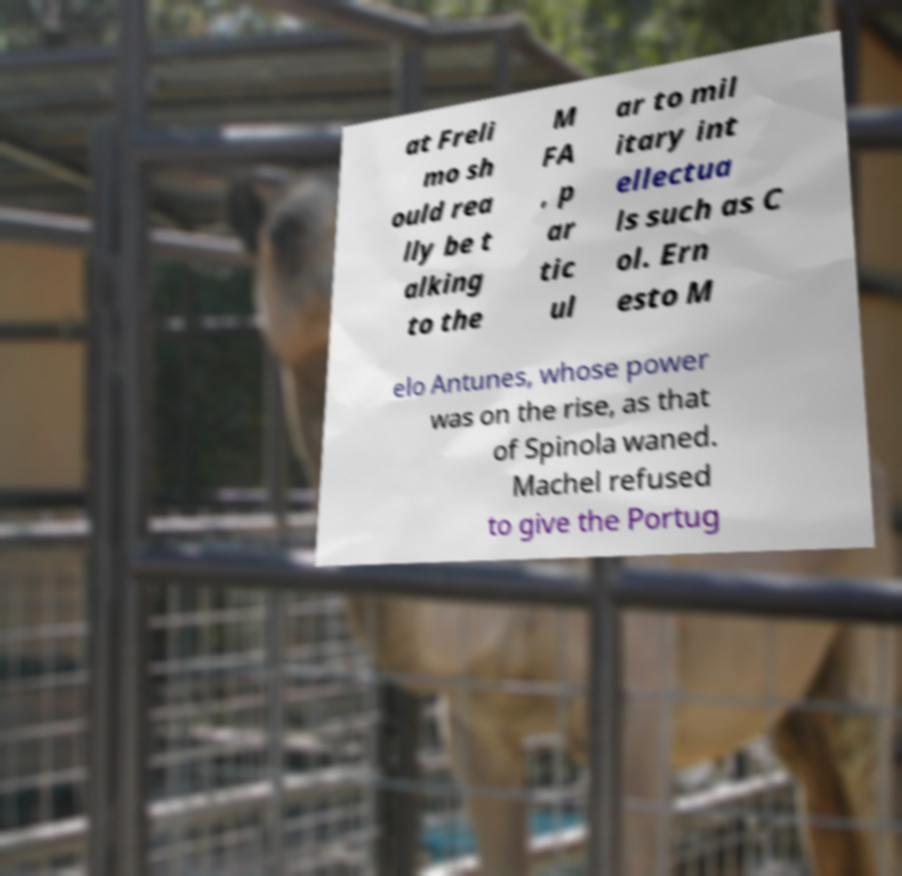Could you assist in decoding the text presented in this image and type it out clearly? at Freli mo sh ould rea lly be t alking to the M FA , p ar tic ul ar to mil itary int ellectua ls such as C ol. Ern esto M elo Antunes, whose power was on the rise, as that of Spinola waned. Machel refused to give the Portug 